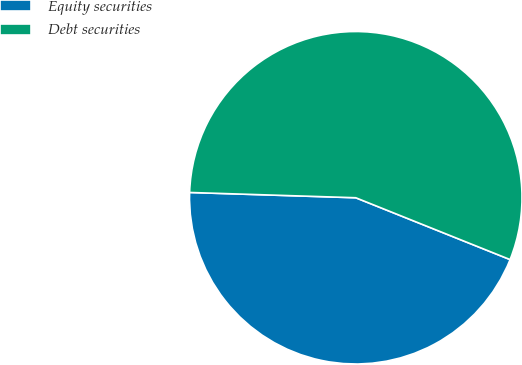Convert chart. <chart><loc_0><loc_0><loc_500><loc_500><pie_chart><fcel>Equity securities<fcel>Debt securities<nl><fcel>44.44%<fcel>55.56%<nl></chart> 